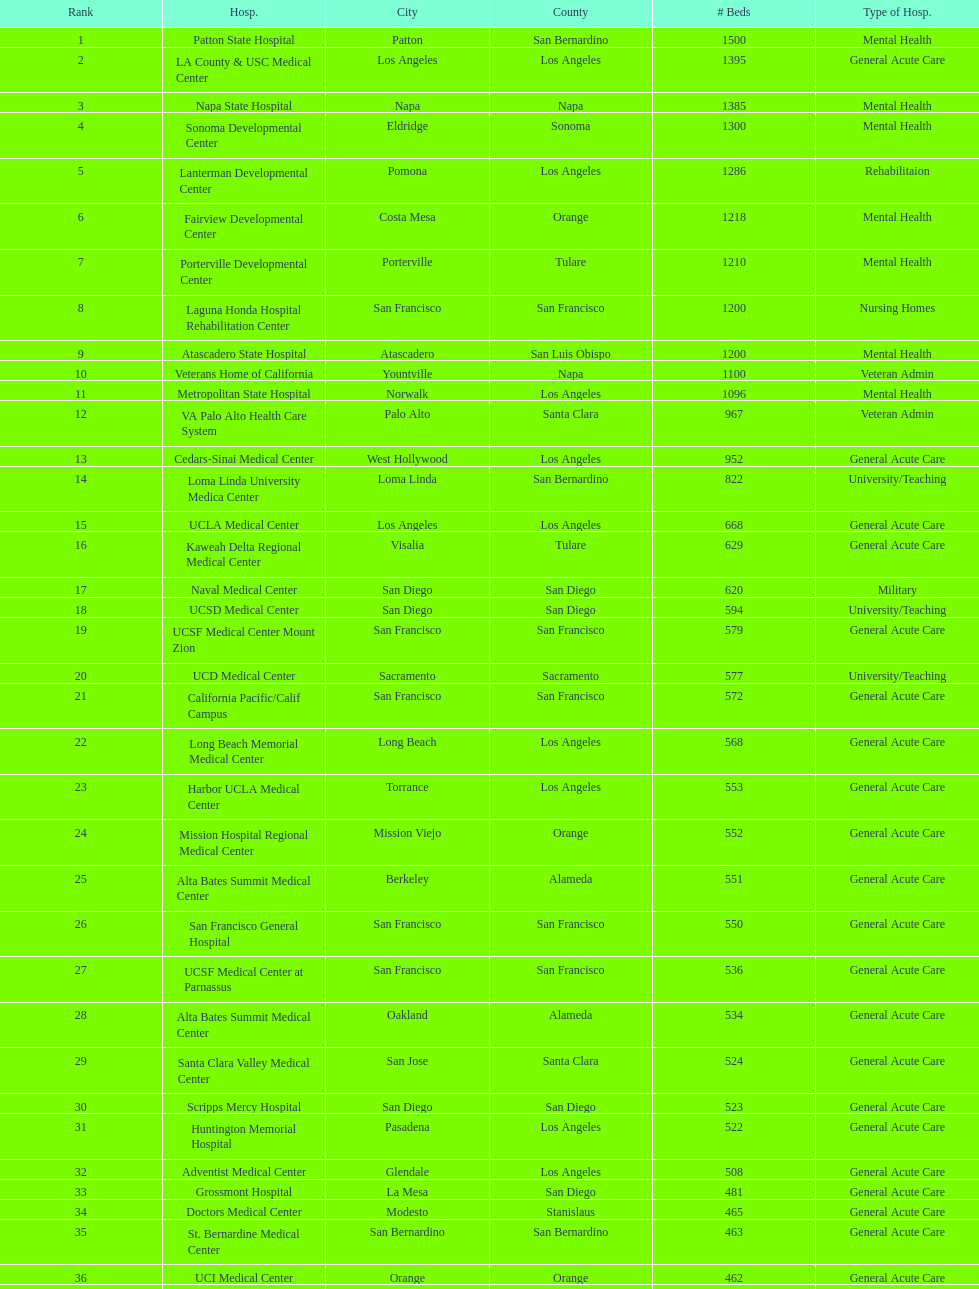What two hospitals holding consecutive rankings of 8 and 9 respectively, both provide 1200 hospital beds? Laguna Honda Hospital Rehabilitation Center, Atascadero State Hospital. 